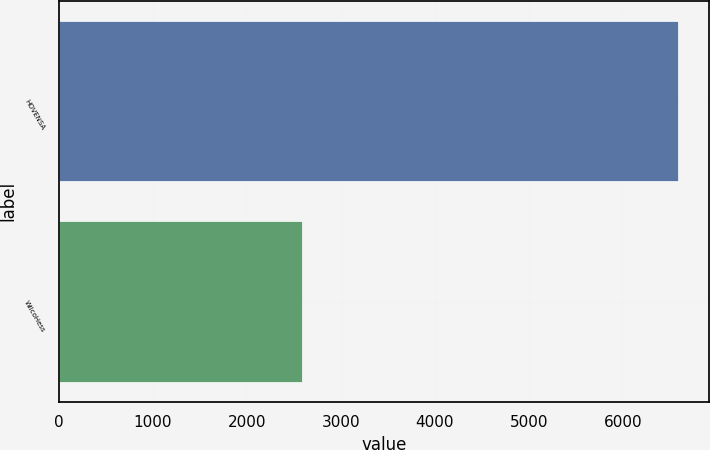Convert chart. <chart><loc_0><loc_0><loc_500><loc_500><bar_chart><fcel>HOVENSA<fcel>WilcoHess<nl><fcel>6589<fcel>2590<nl></chart> 